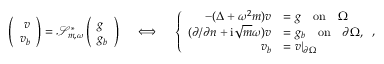<formula> <loc_0><loc_0><loc_500><loc_500>\begin{array} { r } { \left ( \begin{array} { r } { v } \\ { v _ { b } } \end{array} \right ) = \ m a t h s c r { S } _ { m , \omega } ^ { * } \left ( \begin{array} { l } { g } \\ { g _ { b } } \end{array} \right ) \quad \iff \quad \left \{ \begin{array} { r l } { - ( \Delta + \omega ^ { 2 } { m } ) v } & { = g \quad o n \quad \Omega } \\ { ( \partial / \partial n + i \sqrt { m } \omega ) v } & { = g _ { b } \quad o n \quad \partial \Omega , } \\ { v _ { b } } & { = v | _ { \partial \Omega } } \end{array} , } \end{array}</formula> 